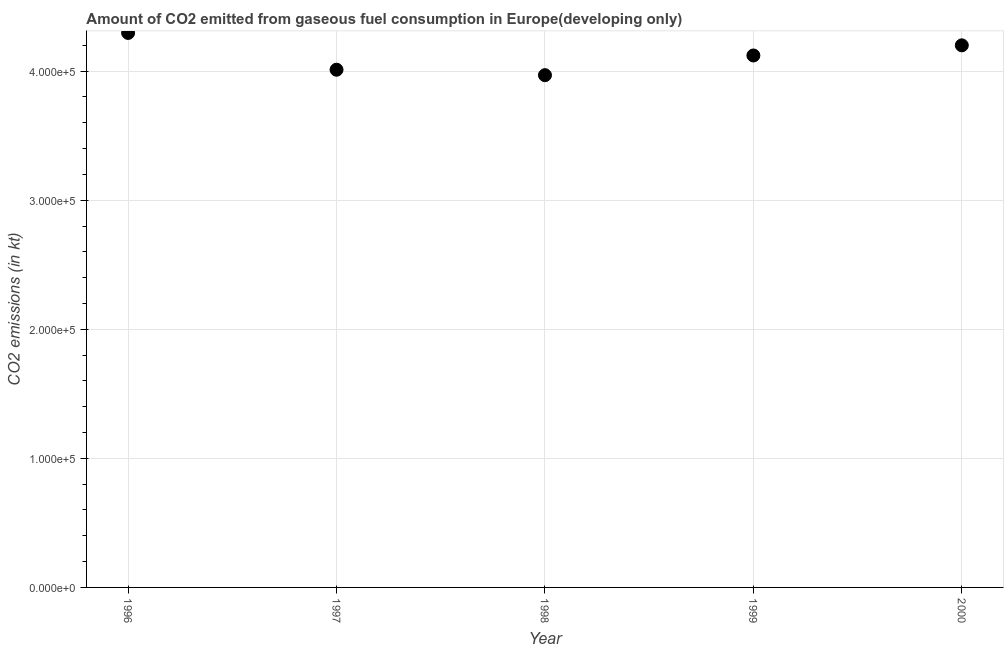What is the co2 emissions from gaseous fuel consumption in 2000?
Make the answer very short. 4.20e+05. Across all years, what is the maximum co2 emissions from gaseous fuel consumption?
Your answer should be compact. 4.30e+05. Across all years, what is the minimum co2 emissions from gaseous fuel consumption?
Your response must be concise. 3.97e+05. In which year was the co2 emissions from gaseous fuel consumption maximum?
Provide a succinct answer. 1996. In which year was the co2 emissions from gaseous fuel consumption minimum?
Your answer should be very brief. 1998. What is the sum of the co2 emissions from gaseous fuel consumption?
Provide a short and direct response. 2.06e+06. What is the difference between the co2 emissions from gaseous fuel consumption in 1997 and 1999?
Provide a succinct answer. -1.10e+04. What is the average co2 emissions from gaseous fuel consumption per year?
Provide a short and direct response. 4.12e+05. What is the median co2 emissions from gaseous fuel consumption?
Your answer should be compact. 4.12e+05. In how many years, is the co2 emissions from gaseous fuel consumption greater than 340000 kt?
Offer a terse response. 5. What is the ratio of the co2 emissions from gaseous fuel consumption in 1999 to that in 2000?
Offer a very short reply. 0.98. What is the difference between the highest and the second highest co2 emissions from gaseous fuel consumption?
Offer a terse response. 9608.75. What is the difference between the highest and the lowest co2 emissions from gaseous fuel consumption?
Give a very brief answer. 3.27e+04. Does the co2 emissions from gaseous fuel consumption monotonically increase over the years?
Offer a very short reply. No. How many dotlines are there?
Keep it short and to the point. 1. How many years are there in the graph?
Your answer should be very brief. 5. Are the values on the major ticks of Y-axis written in scientific E-notation?
Provide a succinct answer. Yes. Does the graph contain any zero values?
Offer a very short reply. No. What is the title of the graph?
Your answer should be compact. Amount of CO2 emitted from gaseous fuel consumption in Europe(developing only). What is the label or title of the X-axis?
Offer a very short reply. Year. What is the label or title of the Y-axis?
Your response must be concise. CO2 emissions (in kt). What is the CO2 emissions (in kt) in 1996?
Your answer should be compact. 4.30e+05. What is the CO2 emissions (in kt) in 1997?
Provide a short and direct response. 4.01e+05. What is the CO2 emissions (in kt) in 1998?
Keep it short and to the point. 3.97e+05. What is the CO2 emissions (in kt) in 1999?
Your response must be concise. 4.12e+05. What is the CO2 emissions (in kt) in 2000?
Your answer should be very brief. 4.20e+05. What is the difference between the CO2 emissions (in kt) in 1996 and 1997?
Provide a short and direct response. 2.85e+04. What is the difference between the CO2 emissions (in kt) in 1996 and 1998?
Your response must be concise. 3.27e+04. What is the difference between the CO2 emissions (in kt) in 1996 and 1999?
Keep it short and to the point. 1.75e+04. What is the difference between the CO2 emissions (in kt) in 1996 and 2000?
Keep it short and to the point. 9608.75. What is the difference between the CO2 emissions (in kt) in 1997 and 1998?
Your answer should be very brief. 4222.8. What is the difference between the CO2 emissions (in kt) in 1997 and 1999?
Provide a short and direct response. -1.10e+04. What is the difference between the CO2 emissions (in kt) in 1997 and 2000?
Ensure brevity in your answer.  -1.89e+04. What is the difference between the CO2 emissions (in kt) in 1998 and 1999?
Give a very brief answer. -1.53e+04. What is the difference between the CO2 emissions (in kt) in 1998 and 2000?
Your response must be concise. -2.31e+04. What is the difference between the CO2 emissions (in kt) in 1999 and 2000?
Keep it short and to the point. -7852.97. What is the ratio of the CO2 emissions (in kt) in 1996 to that in 1997?
Your answer should be compact. 1.07. What is the ratio of the CO2 emissions (in kt) in 1996 to that in 1998?
Provide a short and direct response. 1.08. What is the ratio of the CO2 emissions (in kt) in 1996 to that in 1999?
Your response must be concise. 1.04. What is the ratio of the CO2 emissions (in kt) in 1997 to that in 1999?
Offer a terse response. 0.97. What is the ratio of the CO2 emissions (in kt) in 1997 to that in 2000?
Keep it short and to the point. 0.95. What is the ratio of the CO2 emissions (in kt) in 1998 to that in 2000?
Ensure brevity in your answer.  0.94. What is the ratio of the CO2 emissions (in kt) in 1999 to that in 2000?
Your answer should be very brief. 0.98. 